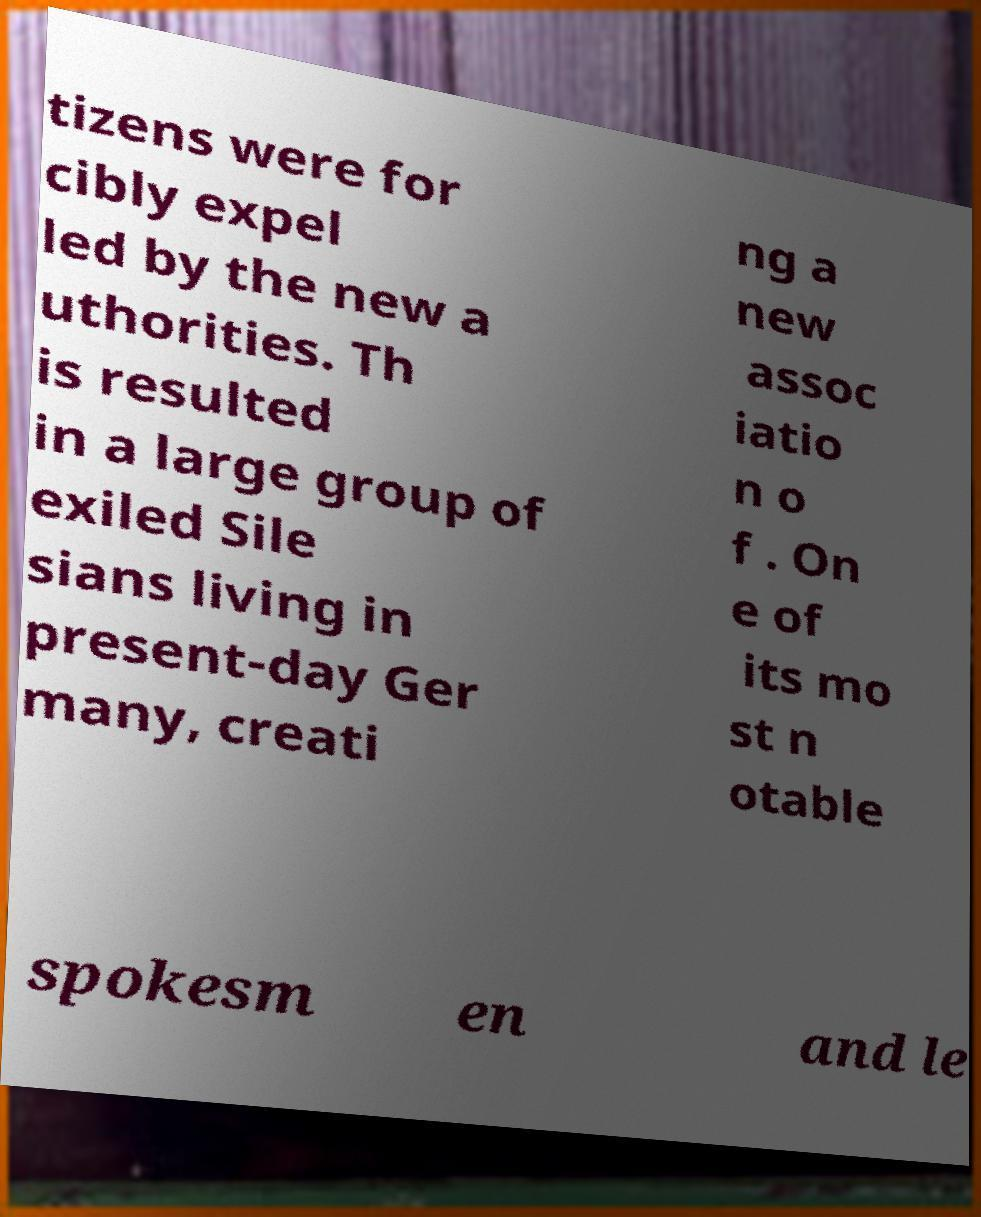There's text embedded in this image that I need extracted. Can you transcribe it verbatim? tizens were for cibly expel led by the new a uthorities. Th is resulted in a large group of exiled Sile sians living in present-day Ger many, creati ng a new assoc iatio n o f . On e of its mo st n otable spokesm en and le 